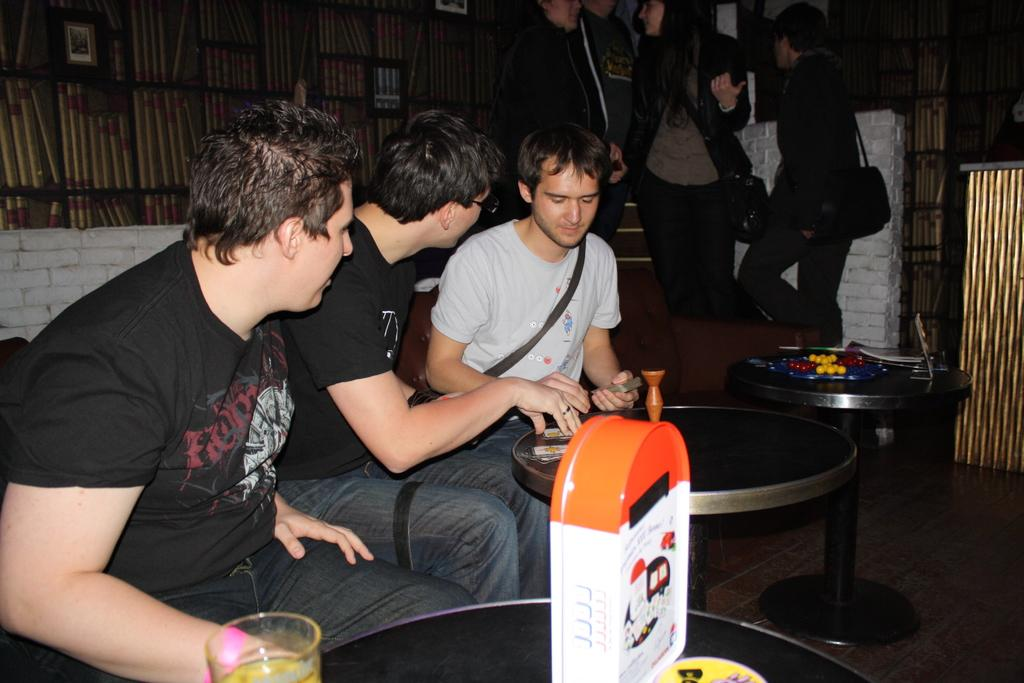How many people are sitting in the image? There are three people sitting on chairs in the image. What is in front of the sitting people? There is a table in front of the sitting people. What are the people on the other side of the table doing? The people on the other side of the table are standing. What type of butter can be seen on the table? There is no butter present on the table in the image. 